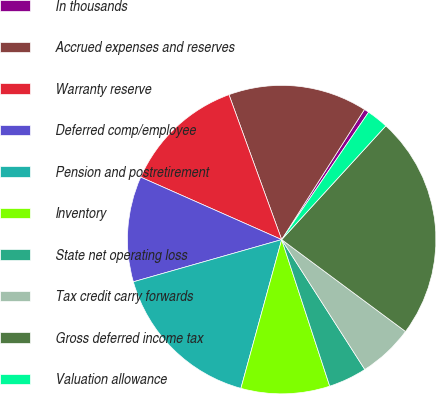Convert chart. <chart><loc_0><loc_0><loc_500><loc_500><pie_chart><fcel>In thousands<fcel>Accrued expenses and reserves<fcel>Warranty reserve<fcel>Deferred comp/employee<fcel>Pension and postretirement<fcel>Inventory<fcel>State net operating loss<fcel>Tax credit carry forwards<fcel>Gross deferred income tax<fcel>Valuation allowance<nl><fcel>0.51%<fcel>14.57%<fcel>12.81%<fcel>11.05%<fcel>16.33%<fcel>9.3%<fcel>4.02%<fcel>5.78%<fcel>23.36%<fcel>2.27%<nl></chart> 